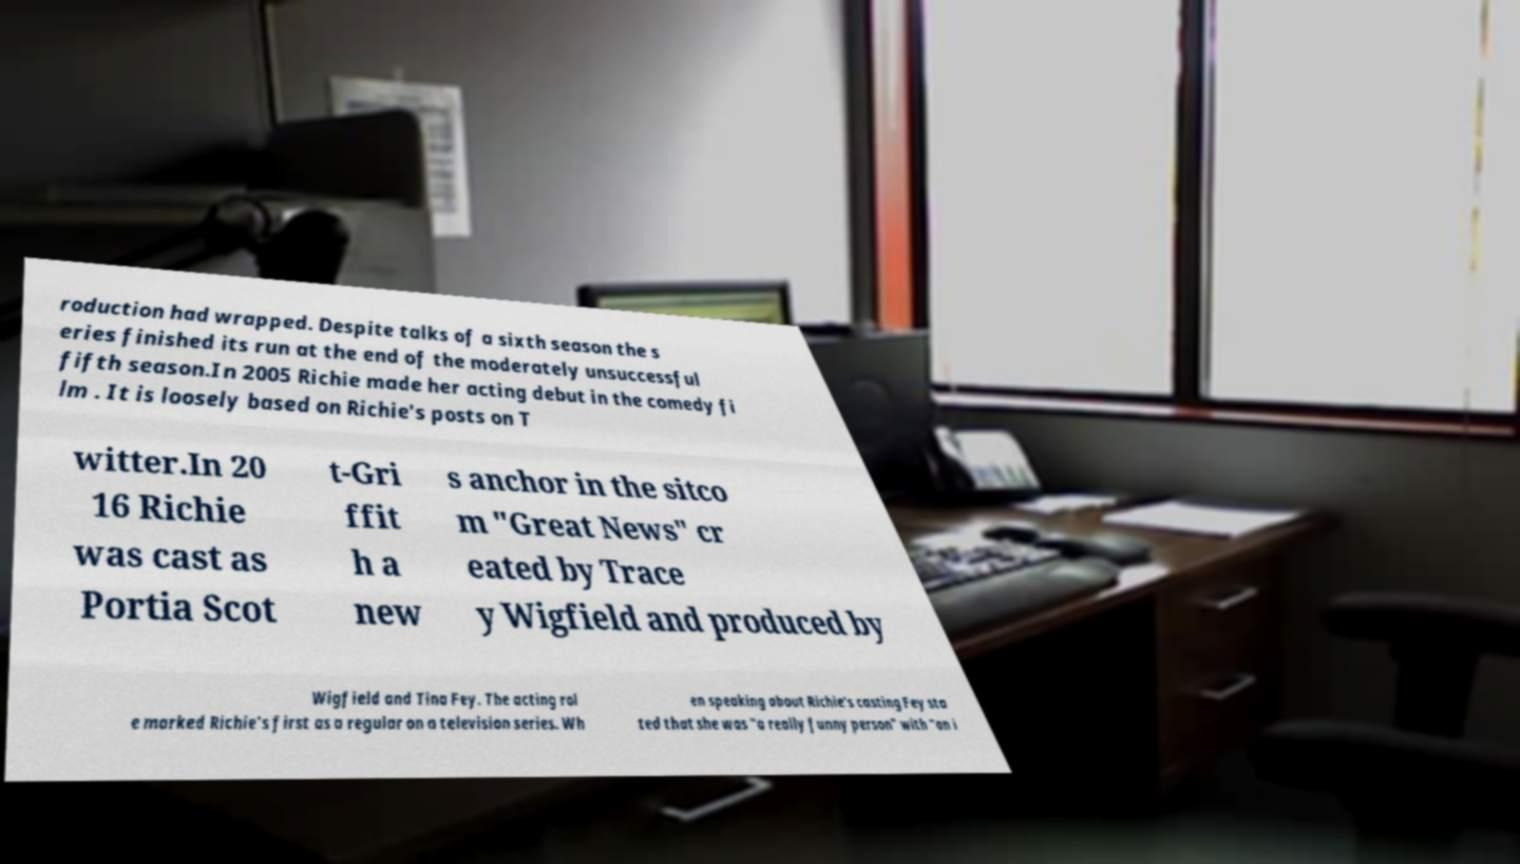Can you read and provide the text displayed in the image?This photo seems to have some interesting text. Can you extract and type it out for me? roduction had wrapped. Despite talks of a sixth season the s eries finished its run at the end of the moderately unsuccessful fifth season.In 2005 Richie made her acting debut in the comedy fi lm . It is loosely based on Richie's posts on T witter.In 20 16 Richie was cast as Portia Scot t-Gri ffit h a new s anchor in the sitco m "Great News" cr eated by Trace y Wigfield and produced by Wigfield and Tina Fey. The acting rol e marked Richie's first as a regular on a television series. Wh en speaking about Richie's casting Fey sta ted that she was "a really funny person" with "an i 